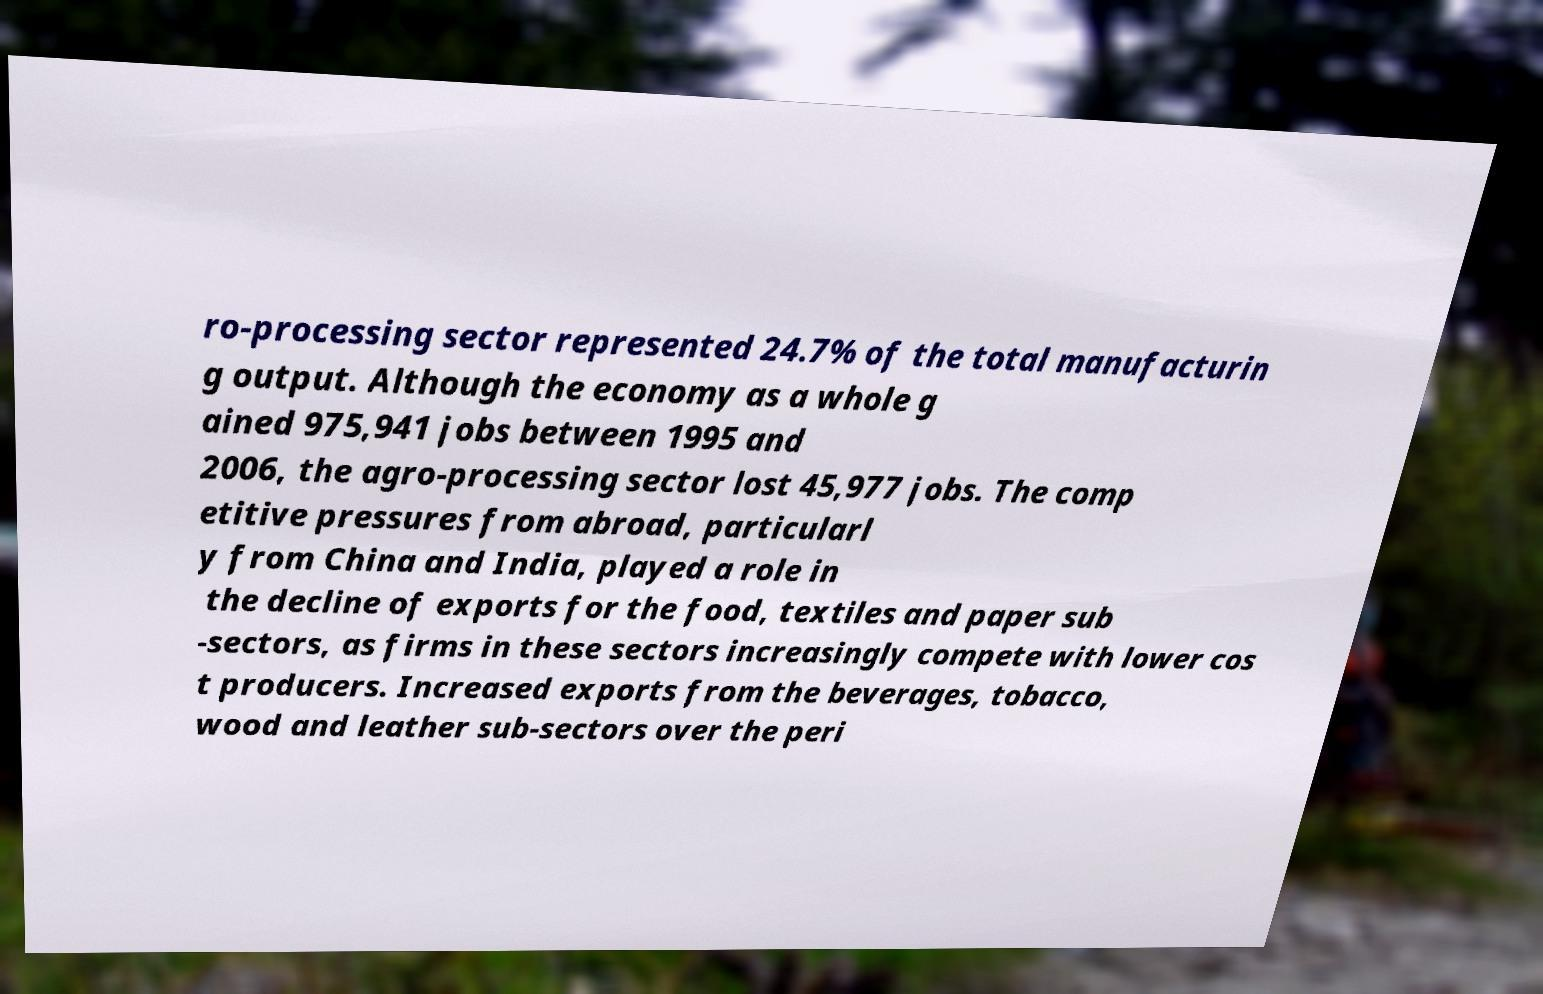Could you extract and type out the text from this image? ro-processing sector represented 24.7% of the total manufacturin g output. Although the economy as a whole g ained 975,941 jobs between 1995 and 2006, the agro-processing sector lost 45,977 jobs. The comp etitive pressures from abroad, particularl y from China and India, played a role in the decline of exports for the food, textiles and paper sub -sectors, as firms in these sectors increasingly compete with lower cos t producers. Increased exports from the beverages, tobacco, wood and leather sub-sectors over the peri 